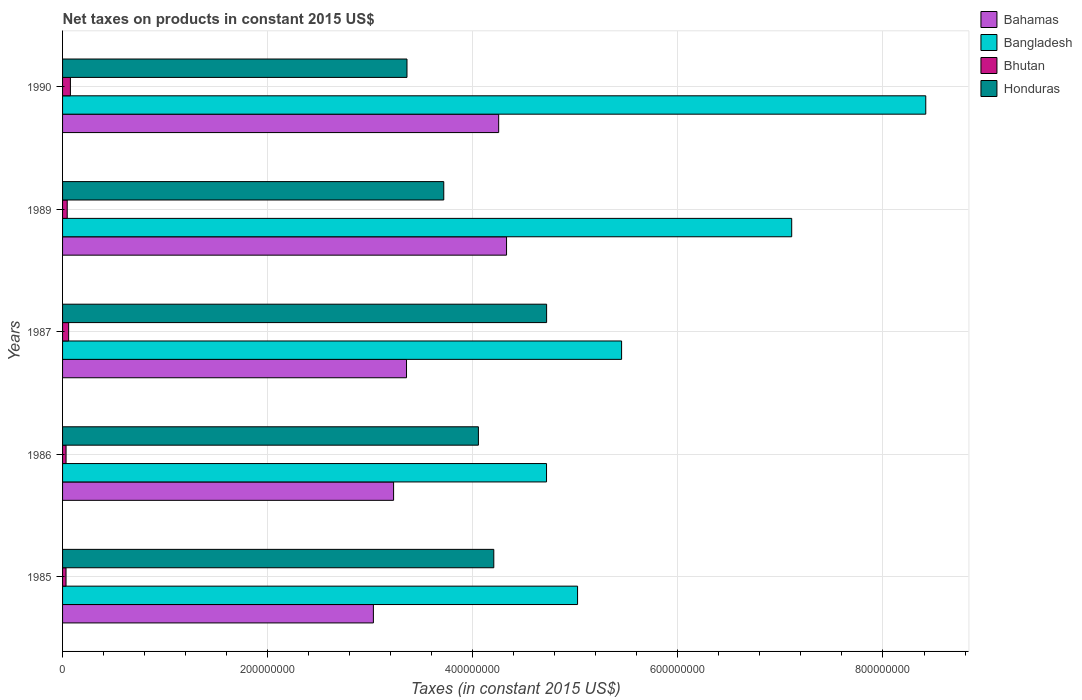Are the number of bars on each tick of the Y-axis equal?
Your answer should be very brief. Yes. How many bars are there on the 3rd tick from the top?
Provide a short and direct response. 4. What is the label of the 1st group of bars from the top?
Provide a short and direct response. 1990. What is the net taxes on products in Bahamas in 1990?
Provide a succinct answer. 4.25e+08. Across all years, what is the maximum net taxes on products in Bahamas?
Your answer should be compact. 4.33e+08. Across all years, what is the minimum net taxes on products in Bangladesh?
Provide a short and direct response. 4.72e+08. In which year was the net taxes on products in Bhutan maximum?
Provide a short and direct response. 1990. What is the total net taxes on products in Bahamas in the graph?
Your response must be concise. 1.82e+09. What is the difference between the net taxes on products in Honduras in 1987 and that in 1990?
Ensure brevity in your answer.  1.36e+08. What is the difference between the net taxes on products in Bahamas in 1987 and the net taxes on products in Bangladesh in 1989?
Provide a succinct answer. -3.76e+08. What is the average net taxes on products in Bhutan per year?
Offer a terse response. 4.98e+06. In the year 1987, what is the difference between the net taxes on products in Honduras and net taxes on products in Bangladesh?
Your answer should be very brief. -7.31e+07. What is the ratio of the net taxes on products in Honduras in 1986 to that in 1990?
Keep it short and to the point. 1.21. Is the net taxes on products in Bahamas in 1985 less than that in 1989?
Offer a very short reply. Yes. What is the difference between the highest and the second highest net taxes on products in Honduras?
Your response must be concise. 5.15e+07. What is the difference between the highest and the lowest net taxes on products in Bahamas?
Provide a short and direct response. 1.30e+08. What does the 1st bar from the top in 1986 represents?
Ensure brevity in your answer.  Honduras. What does the 4th bar from the bottom in 1985 represents?
Make the answer very short. Honduras. Is it the case that in every year, the sum of the net taxes on products in Bhutan and net taxes on products in Bahamas is greater than the net taxes on products in Bangladesh?
Offer a terse response. No. How many bars are there?
Your answer should be compact. 20. How many years are there in the graph?
Provide a succinct answer. 5. Does the graph contain any zero values?
Your answer should be very brief. No. Does the graph contain grids?
Offer a very short reply. Yes. Where does the legend appear in the graph?
Your answer should be very brief. Top right. What is the title of the graph?
Provide a short and direct response. Net taxes on products in constant 2015 US$. Does "High income: nonOECD" appear as one of the legend labels in the graph?
Provide a short and direct response. No. What is the label or title of the X-axis?
Your response must be concise. Taxes (in constant 2015 US$). What is the label or title of the Y-axis?
Your response must be concise. Years. What is the Taxes (in constant 2015 US$) of Bahamas in 1985?
Offer a very short reply. 3.03e+08. What is the Taxes (in constant 2015 US$) in Bangladesh in 1985?
Your response must be concise. 5.02e+08. What is the Taxes (in constant 2015 US$) of Bhutan in 1985?
Provide a short and direct response. 3.38e+06. What is the Taxes (in constant 2015 US$) of Honduras in 1985?
Give a very brief answer. 4.20e+08. What is the Taxes (in constant 2015 US$) of Bahamas in 1986?
Your answer should be compact. 3.23e+08. What is the Taxes (in constant 2015 US$) in Bangladesh in 1986?
Give a very brief answer. 4.72e+08. What is the Taxes (in constant 2015 US$) of Bhutan in 1986?
Your answer should be compact. 3.41e+06. What is the Taxes (in constant 2015 US$) of Honduras in 1986?
Your response must be concise. 4.06e+08. What is the Taxes (in constant 2015 US$) of Bahamas in 1987?
Give a very brief answer. 3.35e+08. What is the Taxes (in constant 2015 US$) of Bangladesh in 1987?
Give a very brief answer. 5.45e+08. What is the Taxes (in constant 2015 US$) of Bhutan in 1987?
Offer a terse response. 5.92e+06. What is the Taxes (in constant 2015 US$) of Honduras in 1987?
Provide a succinct answer. 4.72e+08. What is the Taxes (in constant 2015 US$) in Bahamas in 1989?
Keep it short and to the point. 4.33e+08. What is the Taxes (in constant 2015 US$) of Bangladesh in 1989?
Provide a short and direct response. 7.11e+08. What is the Taxes (in constant 2015 US$) of Bhutan in 1989?
Your answer should be very brief. 4.54e+06. What is the Taxes (in constant 2015 US$) of Honduras in 1989?
Ensure brevity in your answer.  3.72e+08. What is the Taxes (in constant 2015 US$) of Bahamas in 1990?
Provide a succinct answer. 4.25e+08. What is the Taxes (in constant 2015 US$) in Bangladesh in 1990?
Your answer should be very brief. 8.42e+08. What is the Taxes (in constant 2015 US$) in Bhutan in 1990?
Ensure brevity in your answer.  7.65e+06. What is the Taxes (in constant 2015 US$) in Honduras in 1990?
Provide a short and direct response. 3.36e+08. Across all years, what is the maximum Taxes (in constant 2015 US$) in Bahamas?
Keep it short and to the point. 4.33e+08. Across all years, what is the maximum Taxes (in constant 2015 US$) in Bangladesh?
Your answer should be very brief. 8.42e+08. Across all years, what is the maximum Taxes (in constant 2015 US$) in Bhutan?
Ensure brevity in your answer.  7.65e+06. Across all years, what is the maximum Taxes (in constant 2015 US$) in Honduras?
Offer a very short reply. 4.72e+08. Across all years, what is the minimum Taxes (in constant 2015 US$) of Bahamas?
Offer a terse response. 3.03e+08. Across all years, what is the minimum Taxes (in constant 2015 US$) of Bangladesh?
Provide a succinct answer. 4.72e+08. Across all years, what is the minimum Taxes (in constant 2015 US$) of Bhutan?
Your answer should be very brief. 3.38e+06. Across all years, what is the minimum Taxes (in constant 2015 US$) in Honduras?
Make the answer very short. 3.36e+08. What is the total Taxes (in constant 2015 US$) of Bahamas in the graph?
Make the answer very short. 1.82e+09. What is the total Taxes (in constant 2015 US$) of Bangladesh in the graph?
Provide a succinct answer. 3.07e+09. What is the total Taxes (in constant 2015 US$) of Bhutan in the graph?
Give a very brief answer. 2.49e+07. What is the total Taxes (in constant 2015 US$) in Honduras in the graph?
Keep it short and to the point. 2.01e+09. What is the difference between the Taxes (in constant 2015 US$) of Bahamas in 1985 and that in 1986?
Provide a succinct answer. -1.97e+07. What is the difference between the Taxes (in constant 2015 US$) of Bangladesh in 1985 and that in 1986?
Offer a terse response. 3.03e+07. What is the difference between the Taxes (in constant 2015 US$) of Bhutan in 1985 and that in 1986?
Your answer should be compact. -3.08e+04. What is the difference between the Taxes (in constant 2015 US$) of Honduras in 1985 and that in 1986?
Keep it short and to the point. 1.50e+07. What is the difference between the Taxes (in constant 2015 US$) of Bahamas in 1985 and that in 1987?
Offer a very short reply. -3.23e+07. What is the difference between the Taxes (in constant 2015 US$) of Bangladesh in 1985 and that in 1987?
Make the answer very short. -4.29e+07. What is the difference between the Taxes (in constant 2015 US$) of Bhutan in 1985 and that in 1987?
Keep it short and to the point. -2.54e+06. What is the difference between the Taxes (in constant 2015 US$) in Honduras in 1985 and that in 1987?
Your response must be concise. -5.15e+07. What is the difference between the Taxes (in constant 2015 US$) of Bahamas in 1985 and that in 1989?
Offer a terse response. -1.30e+08. What is the difference between the Taxes (in constant 2015 US$) of Bangladesh in 1985 and that in 1989?
Ensure brevity in your answer.  -2.09e+08. What is the difference between the Taxes (in constant 2015 US$) in Bhutan in 1985 and that in 1989?
Your answer should be compact. -1.16e+06. What is the difference between the Taxes (in constant 2015 US$) in Honduras in 1985 and that in 1989?
Your answer should be compact. 4.88e+07. What is the difference between the Taxes (in constant 2015 US$) in Bahamas in 1985 and that in 1990?
Provide a succinct answer. -1.22e+08. What is the difference between the Taxes (in constant 2015 US$) in Bangladesh in 1985 and that in 1990?
Make the answer very short. -3.40e+08. What is the difference between the Taxes (in constant 2015 US$) of Bhutan in 1985 and that in 1990?
Your answer should be very brief. -4.27e+06. What is the difference between the Taxes (in constant 2015 US$) in Honduras in 1985 and that in 1990?
Offer a terse response. 8.47e+07. What is the difference between the Taxes (in constant 2015 US$) of Bahamas in 1986 and that in 1987?
Keep it short and to the point. -1.26e+07. What is the difference between the Taxes (in constant 2015 US$) in Bangladesh in 1986 and that in 1987?
Provide a succinct answer. -7.32e+07. What is the difference between the Taxes (in constant 2015 US$) in Bhutan in 1986 and that in 1987?
Ensure brevity in your answer.  -2.51e+06. What is the difference between the Taxes (in constant 2015 US$) in Honduras in 1986 and that in 1987?
Ensure brevity in your answer.  -6.65e+07. What is the difference between the Taxes (in constant 2015 US$) in Bahamas in 1986 and that in 1989?
Provide a short and direct response. -1.10e+08. What is the difference between the Taxes (in constant 2015 US$) in Bangladesh in 1986 and that in 1989?
Make the answer very short. -2.39e+08. What is the difference between the Taxes (in constant 2015 US$) of Bhutan in 1986 and that in 1989?
Your response must be concise. -1.13e+06. What is the difference between the Taxes (in constant 2015 US$) of Honduras in 1986 and that in 1989?
Offer a very short reply. 3.38e+07. What is the difference between the Taxes (in constant 2015 US$) of Bahamas in 1986 and that in 1990?
Make the answer very short. -1.02e+08. What is the difference between the Taxes (in constant 2015 US$) of Bangladesh in 1986 and that in 1990?
Provide a short and direct response. -3.70e+08. What is the difference between the Taxes (in constant 2015 US$) of Bhutan in 1986 and that in 1990?
Provide a succinct answer. -4.24e+06. What is the difference between the Taxes (in constant 2015 US$) of Honduras in 1986 and that in 1990?
Keep it short and to the point. 6.97e+07. What is the difference between the Taxes (in constant 2015 US$) in Bahamas in 1987 and that in 1989?
Provide a short and direct response. -9.75e+07. What is the difference between the Taxes (in constant 2015 US$) of Bangladesh in 1987 and that in 1989?
Offer a terse response. -1.66e+08. What is the difference between the Taxes (in constant 2015 US$) of Bhutan in 1987 and that in 1989?
Ensure brevity in your answer.  1.38e+06. What is the difference between the Taxes (in constant 2015 US$) of Honduras in 1987 and that in 1989?
Provide a succinct answer. 1.00e+08. What is the difference between the Taxes (in constant 2015 US$) of Bahamas in 1987 and that in 1990?
Your response must be concise. -8.99e+07. What is the difference between the Taxes (in constant 2015 US$) of Bangladesh in 1987 and that in 1990?
Your answer should be very brief. -2.97e+08. What is the difference between the Taxes (in constant 2015 US$) in Bhutan in 1987 and that in 1990?
Offer a very short reply. -1.73e+06. What is the difference between the Taxes (in constant 2015 US$) of Honduras in 1987 and that in 1990?
Ensure brevity in your answer.  1.36e+08. What is the difference between the Taxes (in constant 2015 US$) in Bahamas in 1989 and that in 1990?
Your answer should be compact. 7.67e+06. What is the difference between the Taxes (in constant 2015 US$) of Bangladesh in 1989 and that in 1990?
Provide a succinct answer. -1.31e+08. What is the difference between the Taxes (in constant 2015 US$) in Bhutan in 1989 and that in 1990?
Your answer should be very brief. -3.11e+06. What is the difference between the Taxes (in constant 2015 US$) of Honduras in 1989 and that in 1990?
Your response must be concise. 3.59e+07. What is the difference between the Taxes (in constant 2015 US$) of Bahamas in 1985 and the Taxes (in constant 2015 US$) of Bangladesh in 1986?
Ensure brevity in your answer.  -1.69e+08. What is the difference between the Taxes (in constant 2015 US$) in Bahamas in 1985 and the Taxes (in constant 2015 US$) in Bhutan in 1986?
Provide a short and direct response. 3.00e+08. What is the difference between the Taxes (in constant 2015 US$) of Bahamas in 1985 and the Taxes (in constant 2015 US$) of Honduras in 1986?
Ensure brevity in your answer.  -1.02e+08. What is the difference between the Taxes (in constant 2015 US$) in Bangladesh in 1985 and the Taxes (in constant 2015 US$) in Bhutan in 1986?
Ensure brevity in your answer.  4.99e+08. What is the difference between the Taxes (in constant 2015 US$) in Bangladesh in 1985 and the Taxes (in constant 2015 US$) in Honduras in 1986?
Offer a terse response. 9.67e+07. What is the difference between the Taxes (in constant 2015 US$) of Bhutan in 1985 and the Taxes (in constant 2015 US$) of Honduras in 1986?
Ensure brevity in your answer.  -4.02e+08. What is the difference between the Taxes (in constant 2015 US$) in Bahamas in 1985 and the Taxes (in constant 2015 US$) in Bangladesh in 1987?
Offer a terse response. -2.42e+08. What is the difference between the Taxes (in constant 2015 US$) of Bahamas in 1985 and the Taxes (in constant 2015 US$) of Bhutan in 1987?
Provide a short and direct response. 2.97e+08. What is the difference between the Taxes (in constant 2015 US$) in Bahamas in 1985 and the Taxes (in constant 2015 US$) in Honduras in 1987?
Offer a very short reply. -1.69e+08. What is the difference between the Taxes (in constant 2015 US$) in Bangladesh in 1985 and the Taxes (in constant 2015 US$) in Bhutan in 1987?
Your answer should be very brief. 4.96e+08. What is the difference between the Taxes (in constant 2015 US$) in Bangladesh in 1985 and the Taxes (in constant 2015 US$) in Honduras in 1987?
Offer a terse response. 3.02e+07. What is the difference between the Taxes (in constant 2015 US$) in Bhutan in 1985 and the Taxes (in constant 2015 US$) in Honduras in 1987?
Your answer should be compact. -4.69e+08. What is the difference between the Taxes (in constant 2015 US$) of Bahamas in 1985 and the Taxes (in constant 2015 US$) of Bangladesh in 1989?
Your answer should be compact. -4.08e+08. What is the difference between the Taxes (in constant 2015 US$) in Bahamas in 1985 and the Taxes (in constant 2015 US$) in Bhutan in 1989?
Ensure brevity in your answer.  2.99e+08. What is the difference between the Taxes (in constant 2015 US$) in Bahamas in 1985 and the Taxes (in constant 2015 US$) in Honduras in 1989?
Offer a very short reply. -6.86e+07. What is the difference between the Taxes (in constant 2015 US$) in Bangladesh in 1985 and the Taxes (in constant 2015 US$) in Bhutan in 1989?
Make the answer very short. 4.98e+08. What is the difference between the Taxes (in constant 2015 US$) of Bangladesh in 1985 and the Taxes (in constant 2015 US$) of Honduras in 1989?
Provide a succinct answer. 1.30e+08. What is the difference between the Taxes (in constant 2015 US$) of Bhutan in 1985 and the Taxes (in constant 2015 US$) of Honduras in 1989?
Your response must be concise. -3.68e+08. What is the difference between the Taxes (in constant 2015 US$) in Bahamas in 1985 and the Taxes (in constant 2015 US$) in Bangladesh in 1990?
Provide a short and direct response. -5.39e+08. What is the difference between the Taxes (in constant 2015 US$) in Bahamas in 1985 and the Taxes (in constant 2015 US$) in Bhutan in 1990?
Give a very brief answer. 2.95e+08. What is the difference between the Taxes (in constant 2015 US$) in Bahamas in 1985 and the Taxes (in constant 2015 US$) in Honduras in 1990?
Your answer should be very brief. -3.27e+07. What is the difference between the Taxes (in constant 2015 US$) in Bangladesh in 1985 and the Taxes (in constant 2015 US$) in Bhutan in 1990?
Offer a very short reply. 4.95e+08. What is the difference between the Taxes (in constant 2015 US$) of Bangladesh in 1985 and the Taxes (in constant 2015 US$) of Honduras in 1990?
Make the answer very short. 1.66e+08. What is the difference between the Taxes (in constant 2015 US$) in Bhutan in 1985 and the Taxes (in constant 2015 US$) in Honduras in 1990?
Your response must be concise. -3.32e+08. What is the difference between the Taxes (in constant 2015 US$) of Bahamas in 1986 and the Taxes (in constant 2015 US$) of Bangladesh in 1987?
Provide a short and direct response. -2.22e+08. What is the difference between the Taxes (in constant 2015 US$) of Bahamas in 1986 and the Taxes (in constant 2015 US$) of Bhutan in 1987?
Your answer should be very brief. 3.17e+08. What is the difference between the Taxes (in constant 2015 US$) of Bahamas in 1986 and the Taxes (in constant 2015 US$) of Honduras in 1987?
Give a very brief answer. -1.49e+08. What is the difference between the Taxes (in constant 2015 US$) in Bangladesh in 1986 and the Taxes (in constant 2015 US$) in Bhutan in 1987?
Your answer should be compact. 4.66e+08. What is the difference between the Taxes (in constant 2015 US$) of Bangladesh in 1986 and the Taxes (in constant 2015 US$) of Honduras in 1987?
Give a very brief answer. -6.67e+04. What is the difference between the Taxes (in constant 2015 US$) of Bhutan in 1986 and the Taxes (in constant 2015 US$) of Honduras in 1987?
Your answer should be very brief. -4.69e+08. What is the difference between the Taxes (in constant 2015 US$) in Bahamas in 1986 and the Taxes (in constant 2015 US$) in Bangladesh in 1989?
Provide a short and direct response. -3.88e+08. What is the difference between the Taxes (in constant 2015 US$) in Bahamas in 1986 and the Taxes (in constant 2015 US$) in Bhutan in 1989?
Your response must be concise. 3.18e+08. What is the difference between the Taxes (in constant 2015 US$) of Bahamas in 1986 and the Taxes (in constant 2015 US$) of Honduras in 1989?
Make the answer very short. -4.89e+07. What is the difference between the Taxes (in constant 2015 US$) of Bangladesh in 1986 and the Taxes (in constant 2015 US$) of Bhutan in 1989?
Keep it short and to the point. 4.67e+08. What is the difference between the Taxes (in constant 2015 US$) in Bangladesh in 1986 and the Taxes (in constant 2015 US$) in Honduras in 1989?
Your answer should be compact. 1.00e+08. What is the difference between the Taxes (in constant 2015 US$) in Bhutan in 1986 and the Taxes (in constant 2015 US$) in Honduras in 1989?
Your answer should be compact. -3.68e+08. What is the difference between the Taxes (in constant 2015 US$) in Bahamas in 1986 and the Taxes (in constant 2015 US$) in Bangladesh in 1990?
Give a very brief answer. -5.19e+08. What is the difference between the Taxes (in constant 2015 US$) in Bahamas in 1986 and the Taxes (in constant 2015 US$) in Bhutan in 1990?
Give a very brief answer. 3.15e+08. What is the difference between the Taxes (in constant 2015 US$) in Bahamas in 1986 and the Taxes (in constant 2015 US$) in Honduras in 1990?
Your answer should be very brief. -1.30e+07. What is the difference between the Taxes (in constant 2015 US$) in Bangladesh in 1986 and the Taxes (in constant 2015 US$) in Bhutan in 1990?
Your answer should be very brief. 4.64e+08. What is the difference between the Taxes (in constant 2015 US$) of Bangladesh in 1986 and the Taxes (in constant 2015 US$) of Honduras in 1990?
Your answer should be very brief. 1.36e+08. What is the difference between the Taxes (in constant 2015 US$) in Bhutan in 1986 and the Taxes (in constant 2015 US$) in Honduras in 1990?
Make the answer very short. -3.32e+08. What is the difference between the Taxes (in constant 2015 US$) in Bahamas in 1987 and the Taxes (in constant 2015 US$) in Bangladesh in 1989?
Keep it short and to the point. -3.76e+08. What is the difference between the Taxes (in constant 2015 US$) of Bahamas in 1987 and the Taxes (in constant 2015 US$) of Bhutan in 1989?
Your answer should be very brief. 3.31e+08. What is the difference between the Taxes (in constant 2015 US$) of Bahamas in 1987 and the Taxes (in constant 2015 US$) of Honduras in 1989?
Your answer should be compact. -3.63e+07. What is the difference between the Taxes (in constant 2015 US$) of Bangladesh in 1987 and the Taxes (in constant 2015 US$) of Bhutan in 1989?
Keep it short and to the point. 5.41e+08. What is the difference between the Taxes (in constant 2015 US$) of Bangladesh in 1987 and the Taxes (in constant 2015 US$) of Honduras in 1989?
Your response must be concise. 1.73e+08. What is the difference between the Taxes (in constant 2015 US$) of Bhutan in 1987 and the Taxes (in constant 2015 US$) of Honduras in 1989?
Your answer should be compact. -3.66e+08. What is the difference between the Taxes (in constant 2015 US$) of Bahamas in 1987 and the Taxes (in constant 2015 US$) of Bangladesh in 1990?
Your answer should be very brief. -5.06e+08. What is the difference between the Taxes (in constant 2015 US$) of Bahamas in 1987 and the Taxes (in constant 2015 US$) of Bhutan in 1990?
Ensure brevity in your answer.  3.28e+08. What is the difference between the Taxes (in constant 2015 US$) in Bahamas in 1987 and the Taxes (in constant 2015 US$) in Honduras in 1990?
Provide a short and direct response. -4.48e+05. What is the difference between the Taxes (in constant 2015 US$) of Bangladesh in 1987 and the Taxes (in constant 2015 US$) of Bhutan in 1990?
Offer a terse response. 5.37e+08. What is the difference between the Taxes (in constant 2015 US$) of Bangladesh in 1987 and the Taxes (in constant 2015 US$) of Honduras in 1990?
Provide a short and direct response. 2.09e+08. What is the difference between the Taxes (in constant 2015 US$) of Bhutan in 1987 and the Taxes (in constant 2015 US$) of Honduras in 1990?
Give a very brief answer. -3.30e+08. What is the difference between the Taxes (in constant 2015 US$) of Bahamas in 1989 and the Taxes (in constant 2015 US$) of Bangladesh in 1990?
Make the answer very short. -4.09e+08. What is the difference between the Taxes (in constant 2015 US$) of Bahamas in 1989 and the Taxes (in constant 2015 US$) of Bhutan in 1990?
Provide a short and direct response. 4.25e+08. What is the difference between the Taxes (in constant 2015 US$) of Bahamas in 1989 and the Taxes (in constant 2015 US$) of Honduras in 1990?
Your answer should be very brief. 9.71e+07. What is the difference between the Taxes (in constant 2015 US$) in Bangladesh in 1989 and the Taxes (in constant 2015 US$) in Bhutan in 1990?
Your response must be concise. 7.03e+08. What is the difference between the Taxes (in constant 2015 US$) in Bangladesh in 1989 and the Taxes (in constant 2015 US$) in Honduras in 1990?
Your response must be concise. 3.75e+08. What is the difference between the Taxes (in constant 2015 US$) in Bhutan in 1989 and the Taxes (in constant 2015 US$) in Honduras in 1990?
Make the answer very short. -3.31e+08. What is the average Taxes (in constant 2015 US$) of Bahamas per year?
Your answer should be compact. 3.64e+08. What is the average Taxes (in constant 2015 US$) of Bangladesh per year?
Offer a terse response. 6.14e+08. What is the average Taxes (in constant 2015 US$) in Bhutan per year?
Provide a short and direct response. 4.98e+06. What is the average Taxes (in constant 2015 US$) of Honduras per year?
Offer a very short reply. 4.01e+08. In the year 1985, what is the difference between the Taxes (in constant 2015 US$) of Bahamas and Taxes (in constant 2015 US$) of Bangladesh?
Provide a short and direct response. -1.99e+08. In the year 1985, what is the difference between the Taxes (in constant 2015 US$) of Bahamas and Taxes (in constant 2015 US$) of Bhutan?
Keep it short and to the point. 3.00e+08. In the year 1985, what is the difference between the Taxes (in constant 2015 US$) of Bahamas and Taxes (in constant 2015 US$) of Honduras?
Keep it short and to the point. -1.17e+08. In the year 1985, what is the difference between the Taxes (in constant 2015 US$) of Bangladesh and Taxes (in constant 2015 US$) of Bhutan?
Your answer should be compact. 4.99e+08. In the year 1985, what is the difference between the Taxes (in constant 2015 US$) in Bangladesh and Taxes (in constant 2015 US$) in Honduras?
Make the answer very short. 8.17e+07. In the year 1985, what is the difference between the Taxes (in constant 2015 US$) in Bhutan and Taxes (in constant 2015 US$) in Honduras?
Offer a very short reply. -4.17e+08. In the year 1986, what is the difference between the Taxes (in constant 2015 US$) in Bahamas and Taxes (in constant 2015 US$) in Bangladesh?
Offer a terse response. -1.49e+08. In the year 1986, what is the difference between the Taxes (in constant 2015 US$) in Bahamas and Taxes (in constant 2015 US$) in Bhutan?
Keep it short and to the point. 3.19e+08. In the year 1986, what is the difference between the Taxes (in constant 2015 US$) of Bahamas and Taxes (in constant 2015 US$) of Honduras?
Your answer should be very brief. -8.27e+07. In the year 1986, what is the difference between the Taxes (in constant 2015 US$) of Bangladesh and Taxes (in constant 2015 US$) of Bhutan?
Make the answer very short. 4.69e+08. In the year 1986, what is the difference between the Taxes (in constant 2015 US$) of Bangladesh and Taxes (in constant 2015 US$) of Honduras?
Provide a succinct answer. 6.64e+07. In the year 1986, what is the difference between the Taxes (in constant 2015 US$) of Bhutan and Taxes (in constant 2015 US$) of Honduras?
Offer a terse response. -4.02e+08. In the year 1987, what is the difference between the Taxes (in constant 2015 US$) of Bahamas and Taxes (in constant 2015 US$) of Bangladesh?
Your response must be concise. -2.10e+08. In the year 1987, what is the difference between the Taxes (in constant 2015 US$) of Bahamas and Taxes (in constant 2015 US$) of Bhutan?
Keep it short and to the point. 3.29e+08. In the year 1987, what is the difference between the Taxes (in constant 2015 US$) of Bahamas and Taxes (in constant 2015 US$) of Honduras?
Provide a short and direct response. -1.37e+08. In the year 1987, what is the difference between the Taxes (in constant 2015 US$) of Bangladesh and Taxes (in constant 2015 US$) of Bhutan?
Your response must be concise. 5.39e+08. In the year 1987, what is the difference between the Taxes (in constant 2015 US$) in Bangladesh and Taxes (in constant 2015 US$) in Honduras?
Make the answer very short. 7.31e+07. In the year 1987, what is the difference between the Taxes (in constant 2015 US$) of Bhutan and Taxes (in constant 2015 US$) of Honduras?
Ensure brevity in your answer.  -4.66e+08. In the year 1989, what is the difference between the Taxes (in constant 2015 US$) of Bahamas and Taxes (in constant 2015 US$) of Bangladesh?
Give a very brief answer. -2.78e+08. In the year 1989, what is the difference between the Taxes (in constant 2015 US$) of Bahamas and Taxes (in constant 2015 US$) of Bhutan?
Your answer should be very brief. 4.28e+08. In the year 1989, what is the difference between the Taxes (in constant 2015 US$) of Bahamas and Taxes (in constant 2015 US$) of Honduras?
Provide a short and direct response. 6.12e+07. In the year 1989, what is the difference between the Taxes (in constant 2015 US$) in Bangladesh and Taxes (in constant 2015 US$) in Bhutan?
Your response must be concise. 7.06e+08. In the year 1989, what is the difference between the Taxes (in constant 2015 US$) in Bangladesh and Taxes (in constant 2015 US$) in Honduras?
Ensure brevity in your answer.  3.39e+08. In the year 1989, what is the difference between the Taxes (in constant 2015 US$) in Bhutan and Taxes (in constant 2015 US$) in Honduras?
Your answer should be very brief. -3.67e+08. In the year 1990, what is the difference between the Taxes (in constant 2015 US$) of Bahamas and Taxes (in constant 2015 US$) of Bangladesh?
Keep it short and to the point. -4.16e+08. In the year 1990, what is the difference between the Taxes (in constant 2015 US$) in Bahamas and Taxes (in constant 2015 US$) in Bhutan?
Provide a short and direct response. 4.18e+08. In the year 1990, what is the difference between the Taxes (in constant 2015 US$) in Bahamas and Taxes (in constant 2015 US$) in Honduras?
Give a very brief answer. 8.94e+07. In the year 1990, what is the difference between the Taxes (in constant 2015 US$) of Bangladesh and Taxes (in constant 2015 US$) of Bhutan?
Your answer should be compact. 8.34e+08. In the year 1990, what is the difference between the Taxes (in constant 2015 US$) of Bangladesh and Taxes (in constant 2015 US$) of Honduras?
Provide a short and direct response. 5.06e+08. In the year 1990, what is the difference between the Taxes (in constant 2015 US$) in Bhutan and Taxes (in constant 2015 US$) in Honduras?
Offer a terse response. -3.28e+08. What is the ratio of the Taxes (in constant 2015 US$) of Bahamas in 1985 to that in 1986?
Make the answer very short. 0.94. What is the ratio of the Taxes (in constant 2015 US$) of Bangladesh in 1985 to that in 1986?
Your response must be concise. 1.06. What is the ratio of the Taxes (in constant 2015 US$) of Bhutan in 1985 to that in 1986?
Ensure brevity in your answer.  0.99. What is the ratio of the Taxes (in constant 2015 US$) of Bahamas in 1985 to that in 1987?
Make the answer very short. 0.9. What is the ratio of the Taxes (in constant 2015 US$) of Bangladesh in 1985 to that in 1987?
Offer a terse response. 0.92. What is the ratio of the Taxes (in constant 2015 US$) in Bhutan in 1985 to that in 1987?
Provide a succinct answer. 0.57. What is the ratio of the Taxes (in constant 2015 US$) of Honduras in 1985 to that in 1987?
Ensure brevity in your answer.  0.89. What is the ratio of the Taxes (in constant 2015 US$) of Bahamas in 1985 to that in 1989?
Provide a succinct answer. 0.7. What is the ratio of the Taxes (in constant 2015 US$) in Bangladesh in 1985 to that in 1989?
Keep it short and to the point. 0.71. What is the ratio of the Taxes (in constant 2015 US$) of Bhutan in 1985 to that in 1989?
Give a very brief answer. 0.74. What is the ratio of the Taxes (in constant 2015 US$) in Honduras in 1985 to that in 1989?
Your answer should be compact. 1.13. What is the ratio of the Taxes (in constant 2015 US$) in Bahamas in 1985 to that in 1990?
Your answer should be compact. 0.71. What is the ratio of the Taxes (in constant 2015 US$) in Bangladesh in 1985 to that in 1990?
Give a very brief answer. 0.6. What is the ratio of the Taxes (in constant 2015 US$) of Bhutan in 1985 to that in 1990?
Offer a terse response. 0.44. What is the ratio of the Taxes (in constant 2015 US$) in Honduras in 1985 to that in 1990?
Offer a terse response. 1.25. What is the ratio of the Taxes (in constant 2015 US$) in Bahamas in 1986 to that in 1987?
Make the answer very short. 0.96. What is the ratio of the Taxes (in constant 2015 US$) of Bangladesh in 1986 to that in 1987?
Ensure brevity in your answer.  0.87. What is the ratio of the Taxes (in constant 2015 US$) in Bhutan in 1986 to that in 1987?
Your answer should be compact. 0.58. What is the ratio of the Taxes (in constant 2015 US$) in Honduras in 1986 to that in 1987?
Your answer should be very brief. 0.86. What is the ratio of the Taxes (in constant 2015 US$) in Bahamas in 1986 to that in 1989?
Give a very brief answer. 0.75. What is the ratio of the Taxes (in constant 2015 US$) of Bangladesh in 1986 to that in 1989?
Your answer should be compact. 0.66. What is the ratio of the Taxes (in constant 2015 US$) of Bhutan in 1986 to that in 1989?
Your answer should be compact. 0.75. What is the ratio of the Taxes (in constant 2015 US$) of Bahamas in 1986 to that in 1990?
Your response must be concise. 0.76. What is the ratio of the Taxes (in constant 2015 US$) in Bangladesh in 1986 to that in 1990?
Provide a succinct answer. 0.56. What is the ratio of the Taxes (in constant 2015 US$) of Bhutan in 1986 to that in 1990?
Your answer should be very brief. 0.45. What is the ratio of the Taxes (in constant 2015 US$) of Honduras in 1986 to that in 1990?
Your response must be concise. 1.21. What is the ratio of the Taxes (in constant 2015 US$) of Bahamas in 1987 to that in 1989?
Offer a very short reply. 0.77. What is the ratio of the Taxes (in constant 2015 US$) of Bangladesh in 1987 to that in 1989?
Ensure brevity in your answer.  0.77. What is the ratio of the Taxes (in constant 2015 US$) of Bhutan in 1987 to that in 1989?
Offer a terse response. 1.3. What is the ratio of the Taxes (in constant 2015 US$) in Honduras in 1987 to that in 1989?
Make the answer very short. 1.27. What is the ratio of the Taxes (in constant 2015 US$) of Bahamas in 1987 to that in 1990?
Give a very brief answer. 0.79. What is the ratio of the Taxes (in constant 2015 US$) in Bangladesh in 1987 to that in 1990?
Make the answer very short. 0.65. What is the ratio of the Taxes (in constant 2015 US$) of Bhutan in 1987 to that in 1990?
Your response must be concise. 0.77. What is the ratio of the Taxes (in constant 2015 US$) in Honduras in 1987 to that in 1990?
Make the answer very short. 1.41. What is the ratio of the Taxes (in constant 2015 US$) of Bangladesh in 1989 to that in 1990?
Make the answer very short. 0.84. What is the ratio of the Taxes (in constant 2015 US$) in Bhutan in 1989 to that in 1990?
Provide a short and direct response. 0.59. What is the ratio of the Taxes (in constant 2015 US$) in Honduras in 1989 to that in 1990?
Your answer should be very brief. 1.11. What is the difference between the highest and the second highest Taxes (in constant 2015 US$) of Bahamas?
Provide a succinct answer. 7.67e+06. What is the difference between the highest and the second highest Taxes (in constant 2015 US$) of Bangladesh?
Your answer should be compact. 1.31e+08. What is the difference between the highest and the second highest Taxes (in constant 2015 US$) in Bhutan?
Offer a terse response. 1.73e+06. What is the difference between the highest and the second highest Taxes (in constant 2015 US$) of Honduras?
Ensure brevity in your answer.  5.15e+07. What is the difference between the highest and the lowest Taxes (in constant 2015 US$) in Bahamas?
Ensure brevity in your answer.  1.30e+08. What is the difference between the highest and the lowest Taxes (in constant 2015 US$) of Bangladesh?
Provide a short and direct response. 3.70e+08. What is the difference between the highest and the lowest Taxes (in constant 2015 US$) of Bhutan?
Your answer should be very brief. 4.27e+06. What is the difference between the highest and the lowest Taxes (in constant 2015 US$) in Honduras?
Your answer should be very brief. 1.36e+08. 